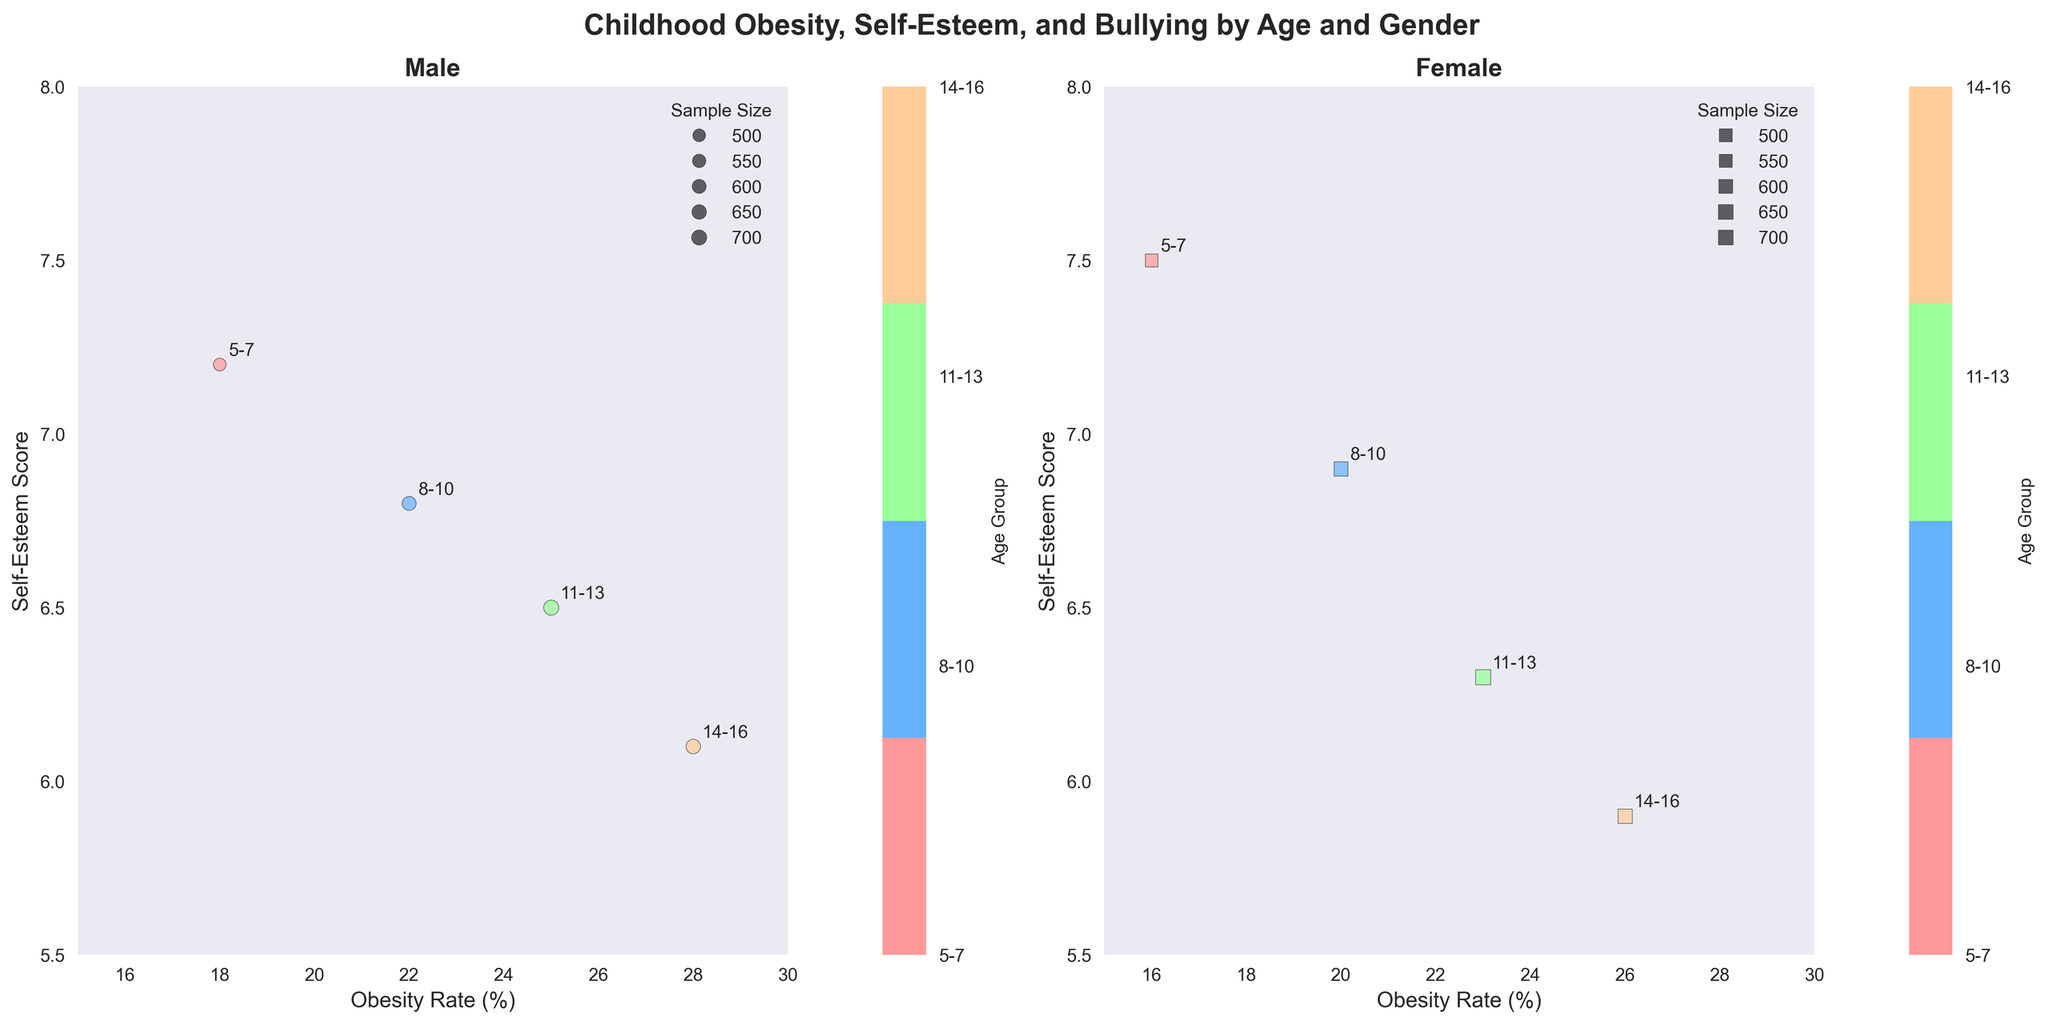What's the title of the subplot? The title of the subplot is usually positioned at the top of the figure and summarizes the content displayed. In this case, the title states the main variables the figure covers.
Answer: Childhood Obesity, Self-Esteem, and Bullying by Age and Gender How does obesity rate change with age in males? To answer this, observe the positions of data points for males on the x-axis (Obesity Rate) across different age groups. Identify if the points are increasing or decreasing along the x-axis as age advances.
Answer: It increases Which gender has higher self-esteem scores in the 5-7 age group? Check the y-axis (Self-Esteem Score) value for both genders in the 5-7 age group. Compare the respective points to determine which one is higher on the y-axis.
Answer: Female What is the general trend of self-esteem scores as age increases for females? Look at the y-axis positions of data points for females across different age groups. Observe if the points trend upwards or downwards as the age groups progress.
Answer: It decreases Which age group experiences the most bullying instances for males? Locate the male subplot and identify which age group has the largest bubble, as bubble size represents the bullying instances.
Answer: 14-16 What's the obesity rate and self-esteem score for 8-10-year-old females? Find the data point for 8-10-year-old females and read the corresponding values on the x-axis (Obesity Rate) and y-axis (Self-Esteem Score).
Answer: 20% (Obesity Rate) and 6.9 (Self-Esteem Score) Do males or females have more variation in self-esteem scores across age groups? Compare the vertical spread (y-axis variability) of the male and female data points in their respective subplots. A broader spread indicates more variation.
Answer: Males Which age group has the lowest self-esteem score for females? Examine the female subplot and locate the data point which lies lowest on the y-axis (Self-Esteem Score). Identify the corresponding age group.
Answer: 14-16 Is there a correlation between obesity rate and self-esteem score across the genders? Notice the general direction or pattern of the data points in the subplots. Positive correlation means both variables increase together, negative means one increases while the other decreases, and no correlation indicates no clear pattern.
Answer: Negative correlation Compare the sample sizes of the 11-13-year-olds. Are males or females better represented? Check the bubble sizes for 11-13-year-olds in both subplots. Larger bubbles indicate larger sample sizes.
Answer: Equal 